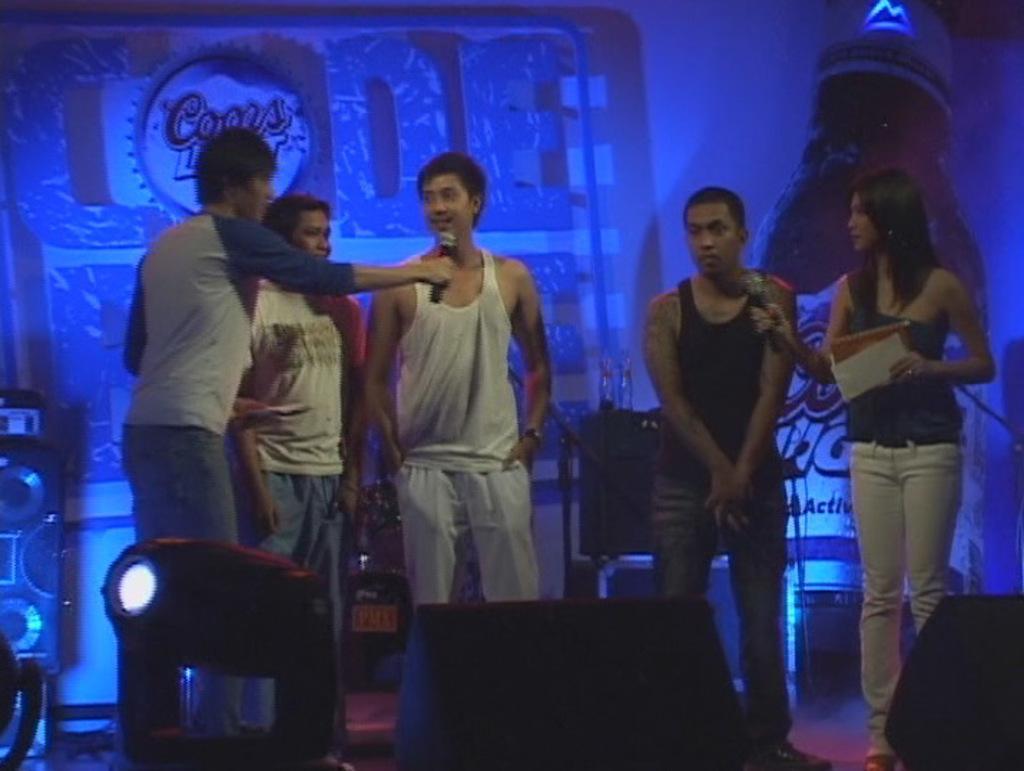Please provide a concise description of this image. Here in this picture we can see a group of people standing over a place and two of them are holding microphones in their hands and the man in the middle is speaking something in the microphone and the woman on the right side is holding some cards in her hand and in front of them we can see speakers and colorful lights present and behind them we can see a banner present and we can also see speakers present. 